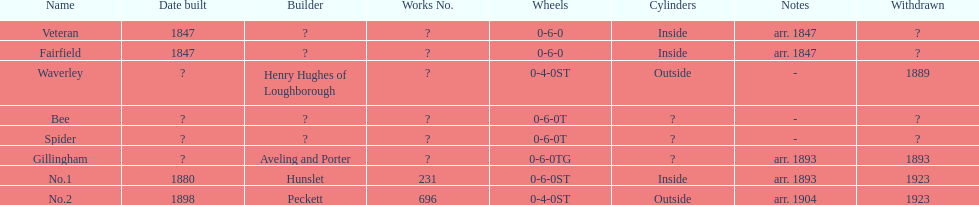What name is listed after spider? Gillingham. 